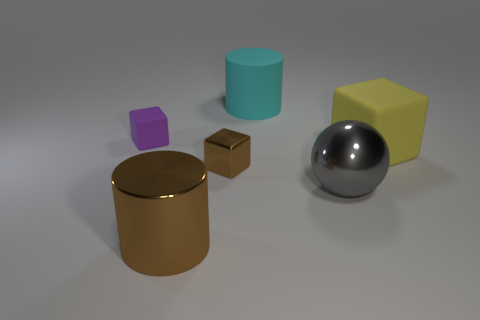Add 2 gray balls. How many objects exist? 8 Subtract all cylinders. How many objects are left? 4 Add 5 purple rubber objects. How many purple rubber objects are left? 6 Add 5 large brown rubber objects. How many large brown rubber objects exist? 5 Subtract 0 yellow cylinders. How many objects are left? 6 Subtract all cyan objects. Subtract all spheres. How many objects are left? 4 